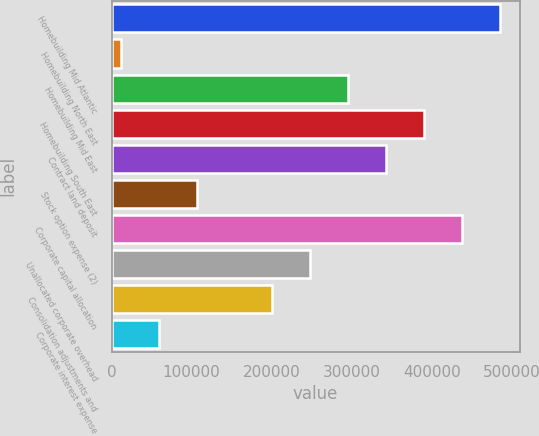Convert chart to OTSL. <chart><loc_0><loc_0><loc_500><loc_500><bar_chart><fcel>Homebuilding Mid Atlantic<fcel>Homebuilding North East<fcel>Homebuilding Mid East<fcel>Homebuilding South East<fcel>Contract land deposit<fcel>Stock option expense (2)<fcel>Corporate capital allocation<fcel>Unallocated corporate overhead<fcel>Consolidation adjustments and<fcel>Corporate interest expense<nl><fcel>485576<fcel>11176<fcel>295816<fcel>390696<fcel>343256<fcel>106056<fcel>438136<fcel>248376<fcel>200936<fcel>58616<nl></chart> 